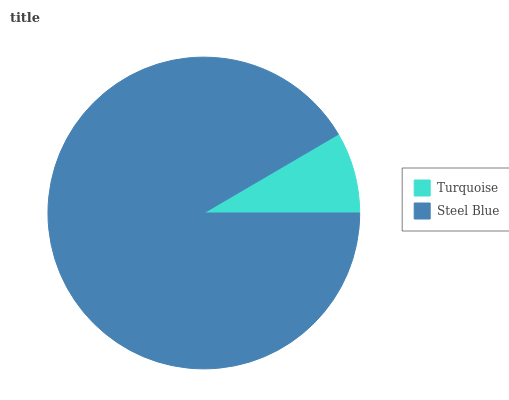Is Turquoise the minimum?
Answer yes or no. Yes. Is Steel Blue the maximum?
Answer yes or no. Yes. Is Steel Blue the minimum?
Answer yes or no. No. Is Steel Blue greater than Turquoise?
Answer yes or no. Yes. Is Turquoise less than Steel Blue?
Answer yes or no. Yes. Is Turquoise greater than Steel Blue?
Answer yes or no. No. Is Steel Blue less than Turquoise?
Answer yes or no. No. Is Steel Blue the high median?
Answer yes or no. Yes. Is Turquoise the low median?
Answer yes or no. Yes. Is Turquoise the high median?
Answer yes or no. No. Is Steel Blue the low median?
Answer yes or no. No. 